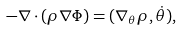<formula> <loc_0><loc_0><loc_500><loc_500>- \nabla \cdot ( \rho \nabla \Phi ) = ( \nabla _ { \theta } \rho , \dot { \theta } ) ,</formula> 